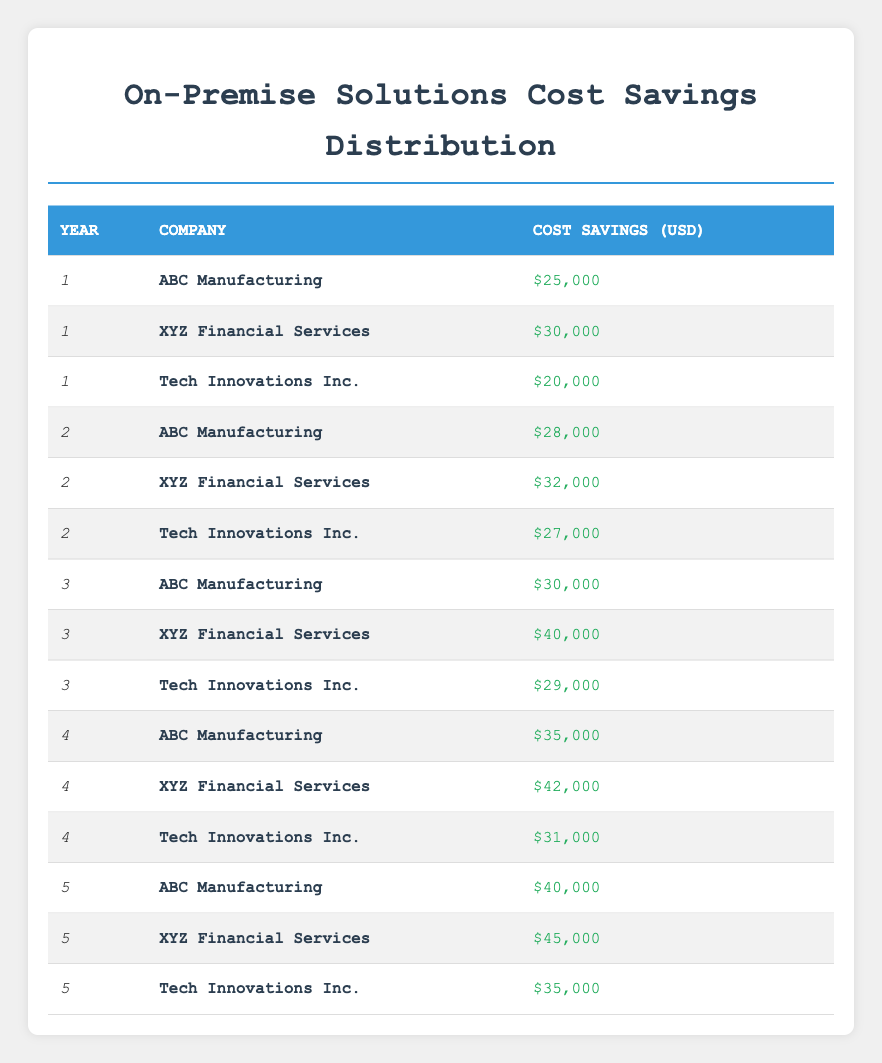What was the cost savings for XYZ Financial Services in the third year? From the table, locate the row where Year is 3 and Company is XYZ Financial Services. The corresponding Cost Savings is $40,000.
Answer: $40,000 How much did ABC Manufacturing save in Year 1 compared to Year 2? In Year 1, ABC Manufacturing saved $25,000 and in Year 2, it saved $28,000. The difference is $28,000 - $25,000 = $3,000.
Answer: $3,000 Did Tech Innovations Inc. have any years where their cost savings were less than $30,000? Looking through all the years for Tech Innovations Inc., the only years with savings below $30,000 are Year 1 ($20,000) and Year 2 ($27,000). Therefore, the answer is yes.
Answer: Yes What is the total cost savings for Tech Innovations Inc. over the five years? Add the cost savings for Tech Innovations Inc. across all years: $20,000 (Year 1) + $27,000 (Year 2) + $29,000 (Year 3) + $31,000 (Year 4) + $35,000 (Year 5) = $142,000.
Answer: $142,000 What is the average cost savings for XYZ Financial Services over the five years? Calculate the total savings: $30,000 + $32,000 + $40,000 + $42,000 + $45,000 = $189,000. Then, divide by the number of years (5) to get the average: $189,000 / 5 = $37,800.
Answer: $37,800 Which company had the highest cost savings in Year 4? In Year 4, the savings for each company are: ABC Manufacturing - $35,000, XYZ Financial Services - $42,000, and Tech Innovations Inc. - $31,000. XYZ Financial Services had the highest savings of $42,000.
Answer: $42,000 What was the total cost savings across all companies in Year 5? For Year 5, the contributions are: ABC Manufacturing - $40,000, XYZ Financial Services - $45,000, and Tech Innovations Inc. - $35,000. Adding these gives $40,000 + $45,000 + $35,000 = $120,000.
Answer: $120,000 Did the total savings for companies increase every year? By comparing totals each year: Year 1 = $75,000, Year 2 = $80,000, Year 3 = $99,000, Year 4 = $108,000, Year 5 = $120,000. The totals consistently increase each year, so the answer is yes.
Answer: Yes 